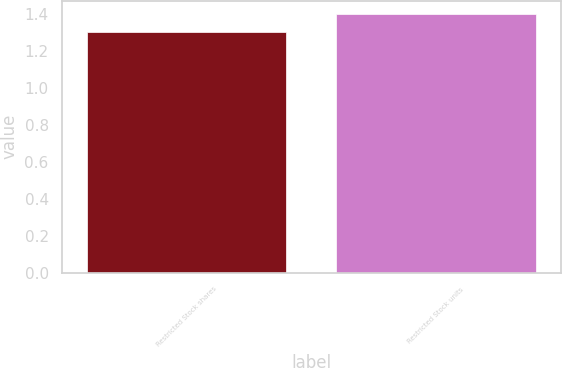Convert chart to OTSL. <chart><loc_0><loc_0><loc_500><loc_500><bar_chart><fcel>Restricted Stock shares<fcel>Restricted Stock units<nl><fcel>1.3<fcel>1.4<nl></chart> 